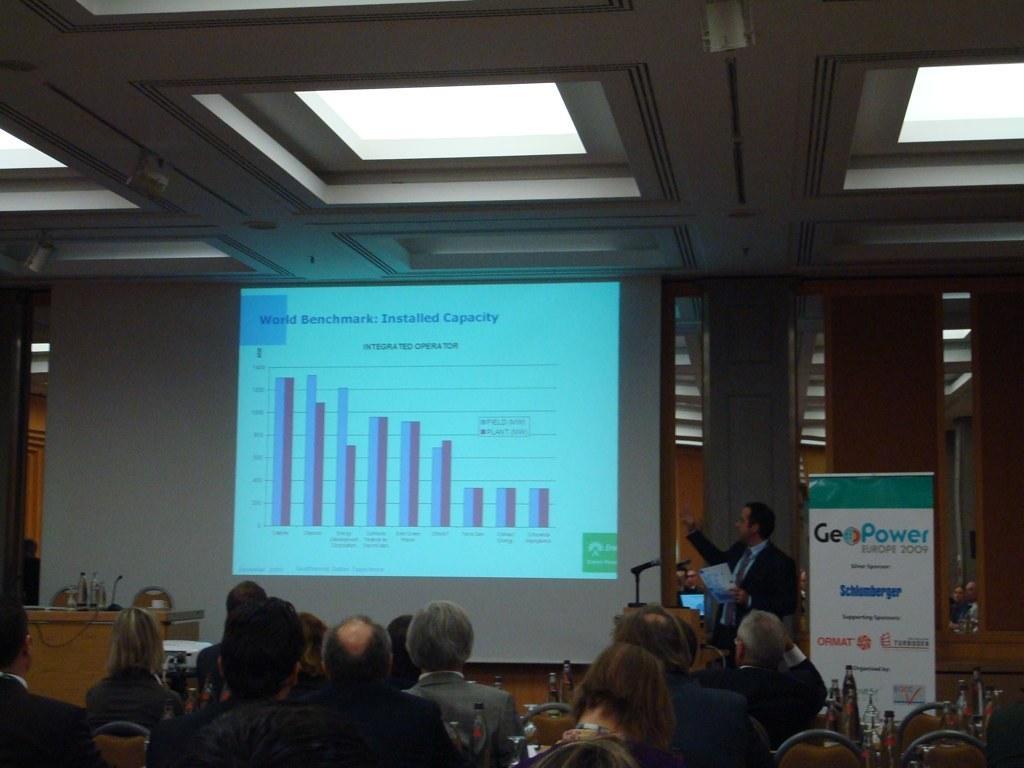In one or two sentences, can you explain what this image depicts? In the picture we can see a meeting hall with some people are sitting near to the table and in front of them we can see a man standing and explaining something and to the wall we can see a screen and some information in it and to the ceiling we can see a glass. 